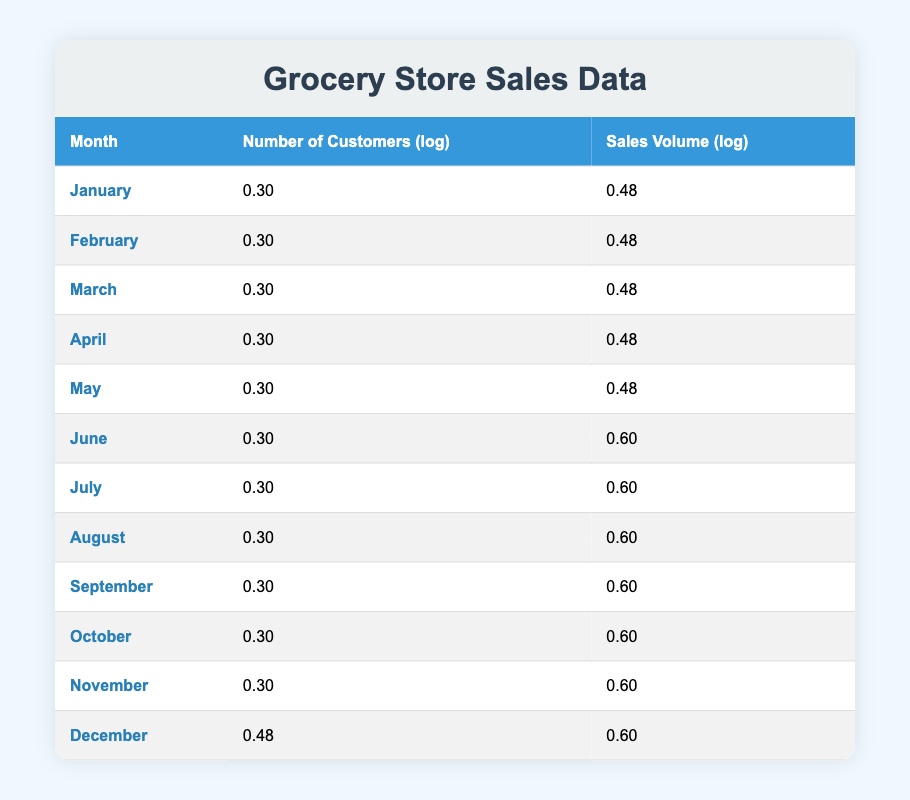What was the sales volume in July? From the table, looking at the row for July, the sales volume is listed directly in the third column as 12000.
Answer: 12000 What is the number of customers in December? The last row of the table shows the month December, and the second column specifies that the number of customers is 1000.
Answer: 1000 Which month had the highest sales volume? By comparing the sales volumes in the table, December has the highest value of 20000, which is greater than all other months.
Answer: December What is the average number of customers from January to April? To find the average: First, sum the number of customers for these months (250 + 300 + 350 + 400) = 1300. Then divide by 4 (the number of months), yielding an average of 1300/4 = 325.
Answer: 325 Did the number of customers increase every month? By examining the second column, the number of customers increases for each consecutive month, confirming that there is no month where it decreases.
Answer: Yes What was the difference in sales volume between January and March? The sales volume for January (5000) and March (7500) are compared. The difference is calculated as 7500 - 5000 = 2500.
Answer: 2500 Is the log sales volume in November greater than in February? The log sales volume for November is 4.28 and for February is 3.78. Since 4.28 is indeed greater than 3.78, the statement is true.
Answer: Yes What is the total sales volume from May to August? The sales volumes for these months are 9000 (May), 10000 (June), 12000 (July), and 14000 (August). Adding these values gives 9000 + 10000 + 12000 + 14000 = 45000.
Answer: 45000 What is the median number of customers for the year? Listing the number of customers in order: 250, 300, 350, 400, 450, 500, 600, 700, 800, 900, 950, 1000. There are 12 values, and the median is the average of the 6th and 7th numbers (500 and 600), so (500 + 600) / 2 = 550.
Answer: 550 